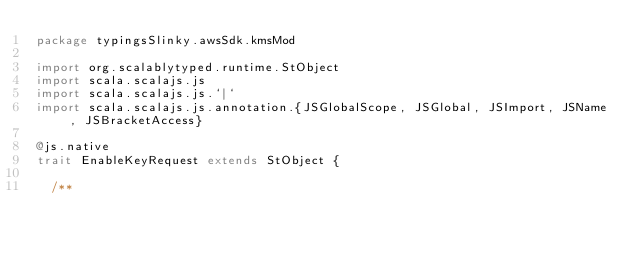<code> <loc_0><loc_0><loc_500><loc_500><_Scala_>package typingsSlinky.awsSdk.kmsMod

import org.scalablytyped.runtime.StObject
import scala.scalajs.js
import scala.scalajs.js.`|`
import scala.scalajs.js.annotation.{JSGlobalScope, JSGlobal, JSImport, JSName, JSBracketAccess}

@js.native
trait EnableKeyRequest extends StObject {
  
  /**</code> 